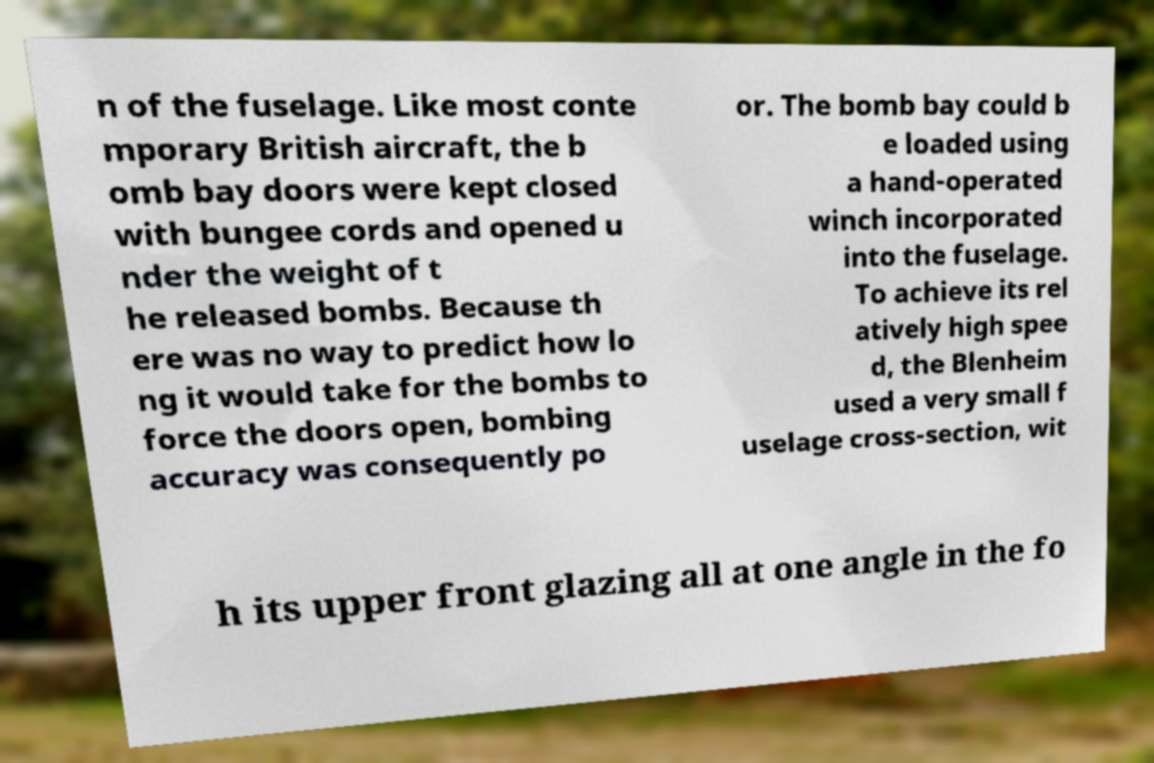For documentation purposes, I need the text within this image transcribed. Could you provide that? n of the fuselage. Like most conte mporary British aircraft, the b omb bay doors were kept closed with bungee cords and opened u nder the weight of t he released bombs. Because th ere was no way to predict how lo ng it would take for the bombs to force the doors open, bombing accuracy was consequently po or. The bomb bay could b e loaded using a hand-operated winch incorporated into the fuselage. To achieve its rel atively high spee d, the Blenheim used a very small f uselage cross-section, wit h its upper front glazing all at one angle in the fo 